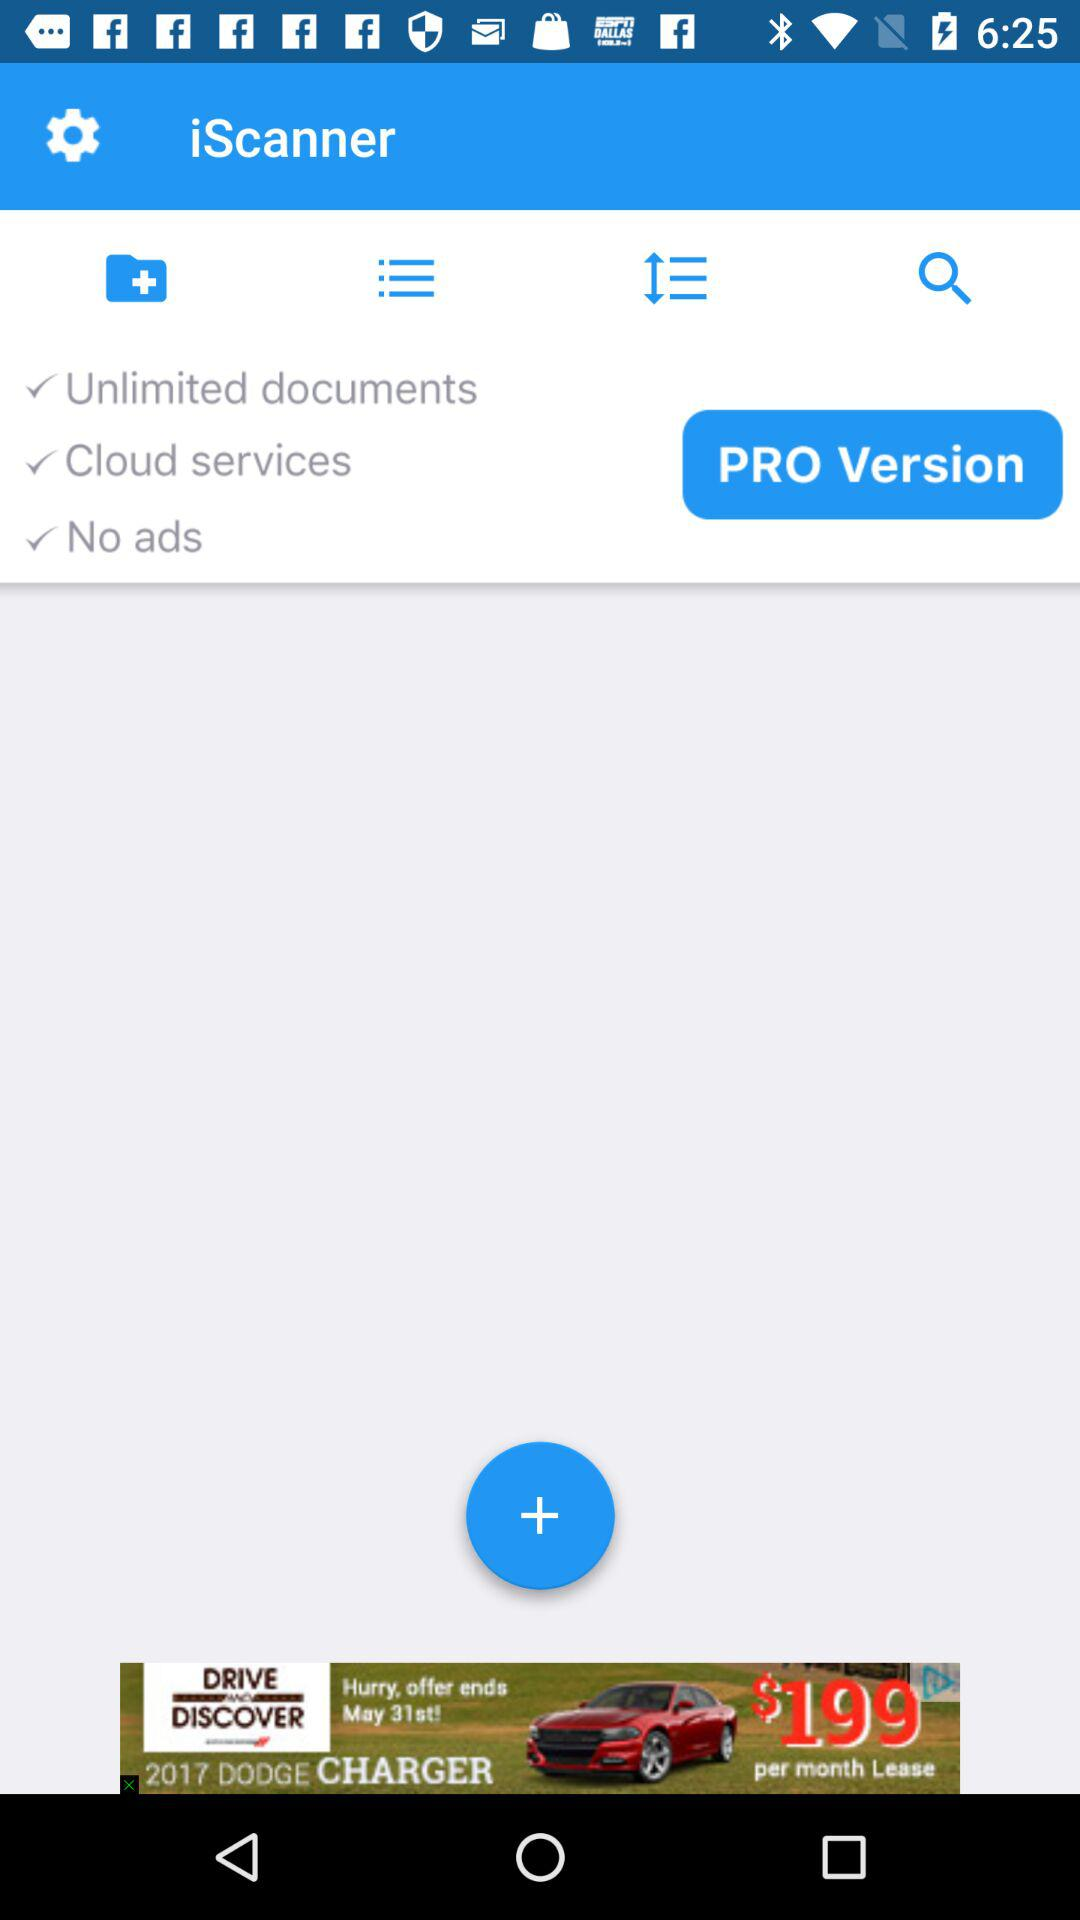What is the name of the application? The name of the application is "iScanner". 